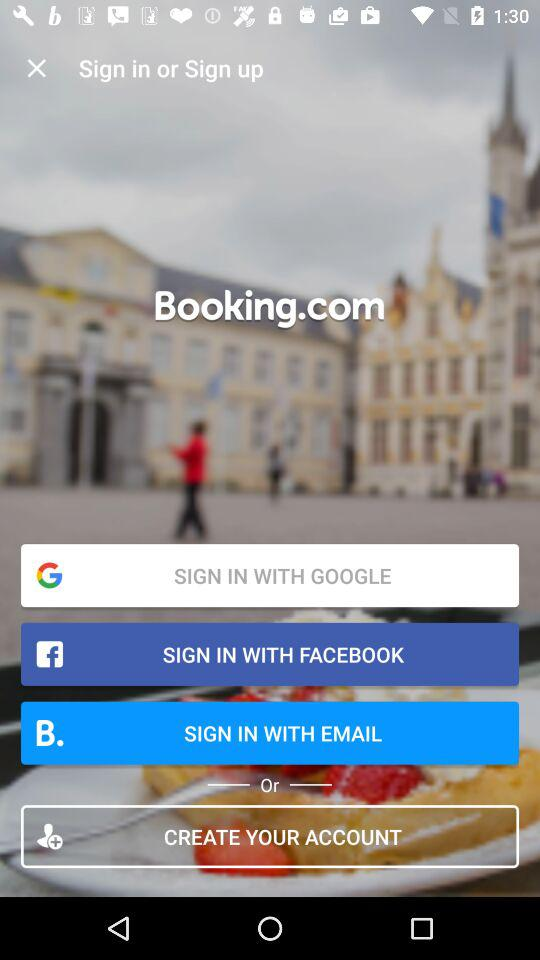How many reviews are there?
When the provided information is insufficient, respond with <no answer>. <no answer> 